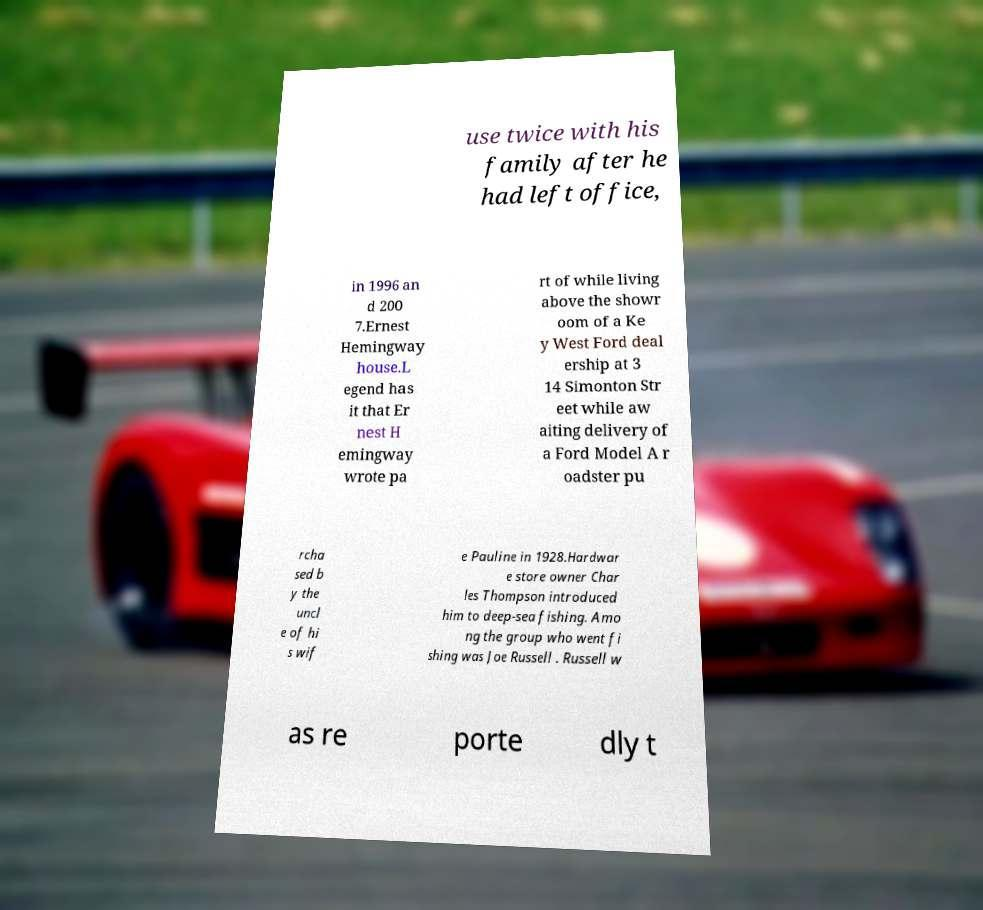I need the written content from this picture converted into text. Can you do that? use twice with his family after he had left office, in 1996 an d 200 7.Ernest Hemingway house.L egend has it that Er nest H emingway wrote pa rt of while living above the showr oom of a Ke y West Ford deal ership at 3 14 Simonton Str eet while aw aiting delivery of a Ford Model A r oadster pu rcha sed b y the uncl e of hi s wif e Pauline in 1928.Hardwar e store owner Char les Thompson introduced him to deep-sea fishing. Amo ng the group who went fi shing was Joe Russell . Russell w as re porte dly t 